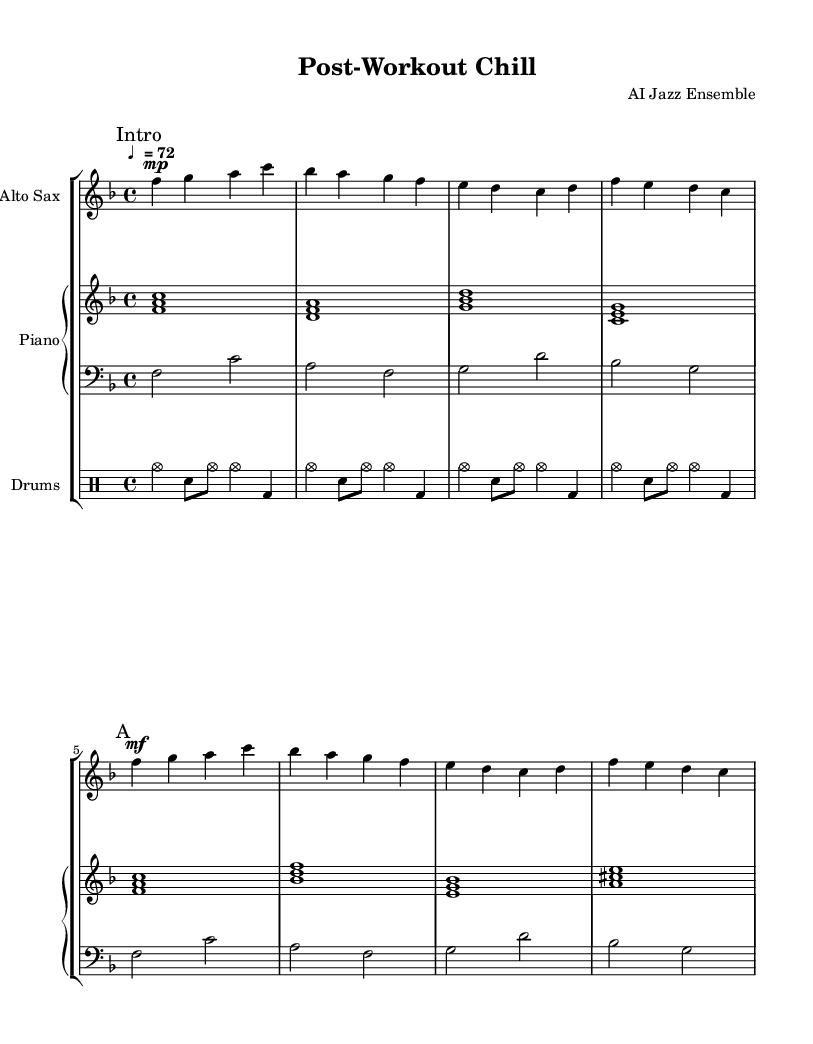What is the key signature of this music? The key signature shows one flat (B♭), indicating it is in the key of F major.
Answer: F major What is the time signature of this music? The time signature is 4/4, meaning there are four beats in a measure and the quarter note gets one beat.
Answer: 4/4 What is the tempo marking of this piece? The tempo marking is "♩ = 72", indicating a moderate speed at which the piece should be played.
Answer: 72 What instruments are featured in this piece? The music includes Alto Saxophone, Piano, Bass, and Drums as indicated by the staff names and groups in the score.
Answer: Alto Saxophone, Piano, Bass, Drums How many measures are in section "A"? The "A" section consists of four measures as determined by the presence of four groups of notes based on the provided structure.
Answer: 4 What is the dynamic marking at the beginning of the piece? The dynamic marking at the beginning is "mp," which stands for mezzo-piano, meaning moderately soft.
Answer: mezzo-piano What style is this piece classified as? This piece is classified as "Cool Jazz," characterized by its mellow and laid-back style, suitable for unwinding after workouts.
Answer: Cool Jazz 